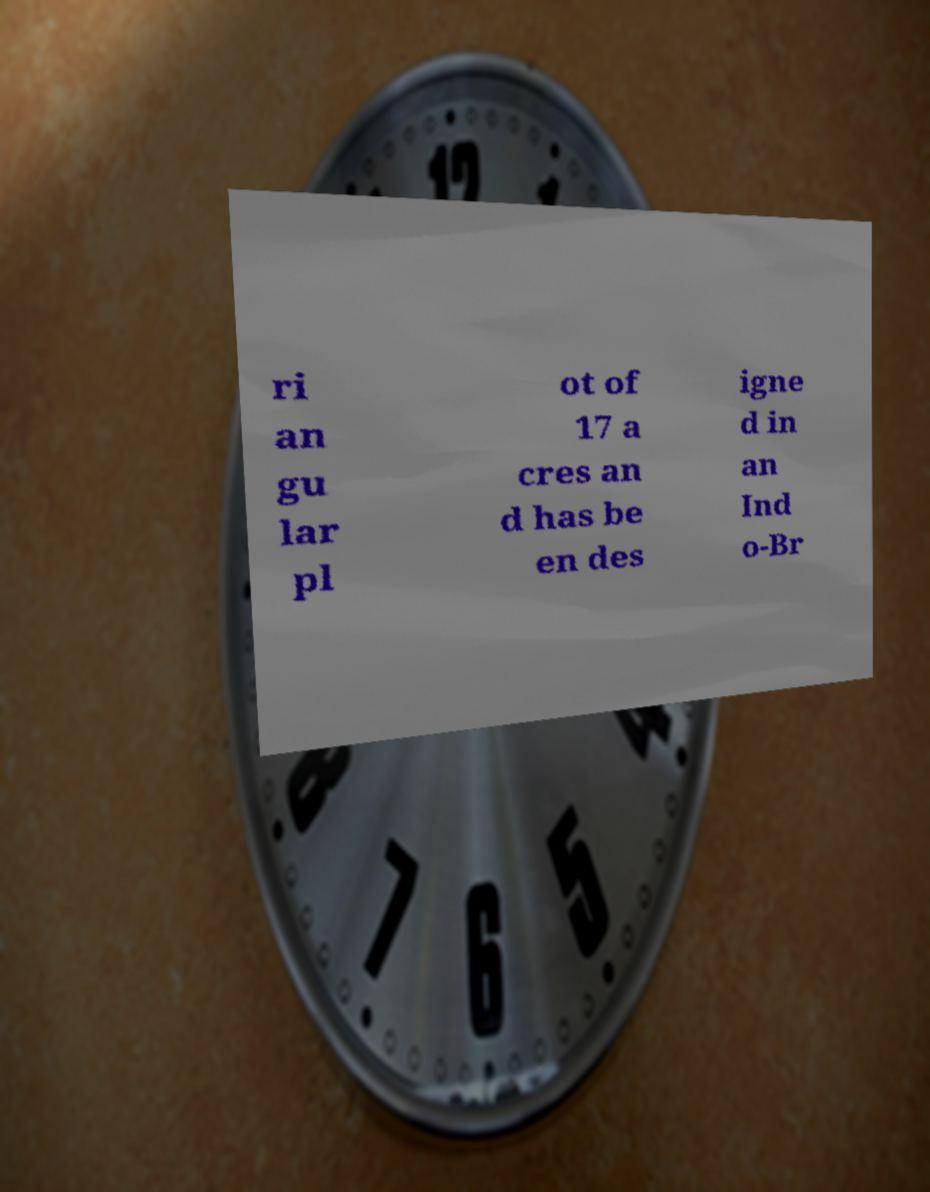Please identify and transcribe the text found in this image. ri an gu lar pl ot of 17 a cres an d has be en des igne d in an Ind o-Br 